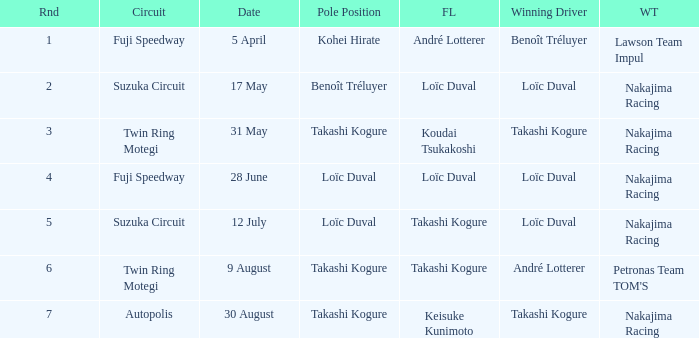Who has the fastest lap where Benoît Tréluyer got the pole position? Loïc Duval. 